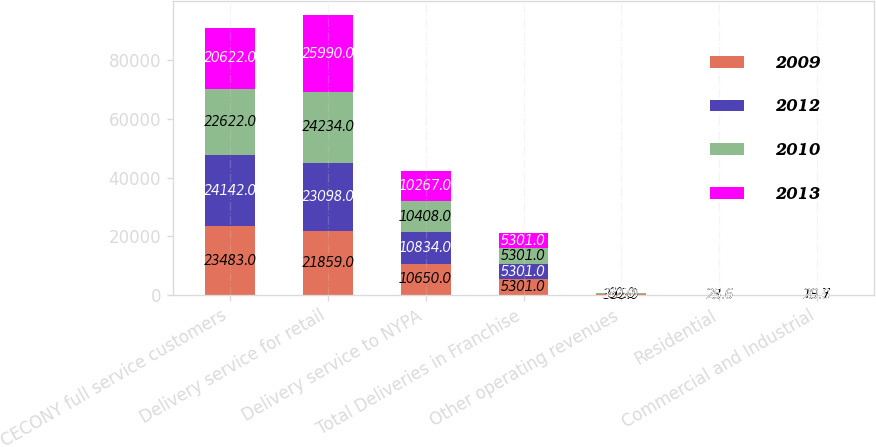Convert chart. <chart><loc_0><loc_0><loc_500><loc_500><stacked_bar_chart><ecel><fcel>CECONY full service customers<fcel>Delivery service for retail<fcel>Delivery service to NYPA<fcel>Total Deliveries in Franchise<fcel>Other operating revenues<fcel>Residential<fcel>Commercial and Industrial<nl><fcel>2009<fcel>23483<fcel>21859<fcel>10650<fcel>5301<fcel>335<fcel>23.6<fcel>19.6<nl><fcel>2012<fcel>24142<fcel>23098<fcel>10834<fcel>5301<fcel>169<fcel>25.8<fcel>20.4<nl><fcel>2010<fcel>22622<fcel>24234<fcel>10408<fcel>5301<fcel>60<fcel>25.6<fcel>20.7<nl><fcel>2013<fcel>20622<fcel>25990<fcel>10267<fcel>5301<fcel>89<fcel>25.6<fcel>20<nl></chart> 